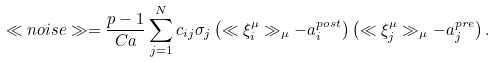Convert formula to latex. <formula><loc_0><loc_0><loc_500><loc_500>\ll n o i s e \gg = \frac { p - 1 } { C a } \sum _ { j = 1 } ^ { N } c _ { i j } \sigma _ { j } \left ( \ll \xi _ { i } ^ { \mu } \gg _ { \mu } - a _ { i } ^ { p o s t } \right ) \left ( \ll \xi _ { j } ^ { \mu } \gg _ { \mu } - a _ { j } ^ { p r e } \right ) .</formula> 